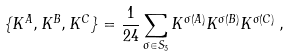Convert formula to latex. <formula><loc_0><loc_0><loc_500><loc_500>\{ K ^ { A } , K ^ { B } , K ^ { C } \} = \frac { 1 } { 2 4 } \sum _ { \sigma \in S _ { 3 } } K ^ { \sigma ( A ) } K ^ { \sigma ( B ) } K ^ { \sigma ( C ) } \, ,</formula> 